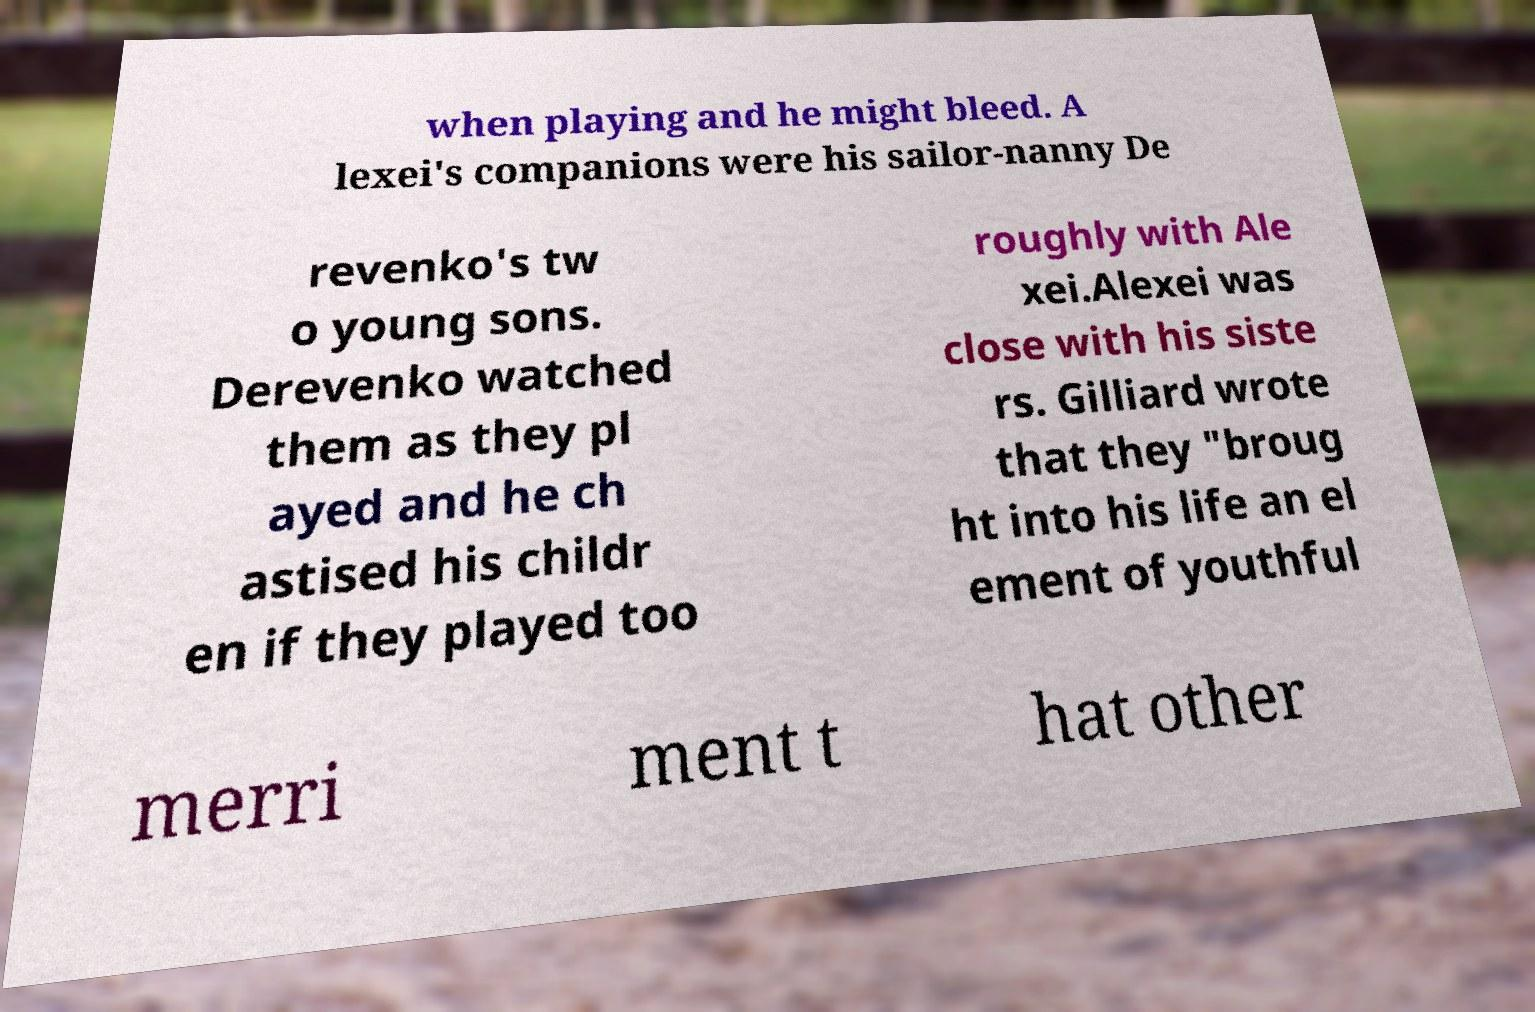Can you read and provide the text displayed in the image?This photo seems to have some interesting text. Can you extract and type it out for me? when playing and he might bleed. A lexei's companions were his sailor-nanny De revenko's tw o young sons. Derevenko watched them as they pl ayed and he ch astised his childr en if they played too roughly with Ale xei.Alexei was close with his siste rs. Gilliard wrote that they "broug ht into his life an el ement of youthful merri ment t hat other 